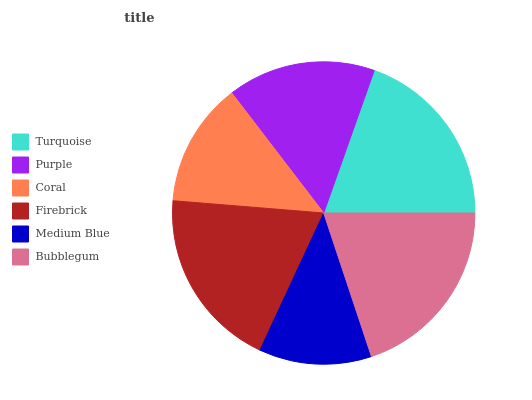Is Medium Blue the minimum?
Answer yes or no. Yes. Is Bubblegum the maximum?
Answer yes or no. Yes. Is Purple the minimum?
Answer yes or no. No. Is Purple the maximum?
Answer yes or no. No. Is Turquoise greater than Purple?
Answer yes or no. Yes. Is Purple less than Turquoise?
Answer yes or no. Yes. Is Purple greater than Turquoise?
Answer yes or no. No. Is Turquoise less than Purple?
Answer yes or no. No. Is Firebrick the high median?
Answer yes or no. Yes. Is Purple the low median?
Answer yes or no. Yes. Is Coral the high median?
Answer yes or no. No. Is Medium Blue the low median?
Answer yes or no. No. 